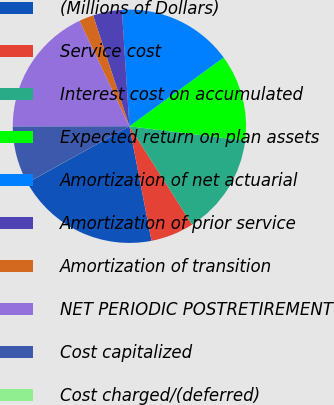Convert chart. <chart><loc_0><loc_0><loc_500><loc_500><pie_chart><fcel>(Millions of Dollars)<fcel>Service cost<fcel>Interest cost on accumulated<fcel>Expected return on plan assets<fcel>Amortization of net actuarial<fcel>Amortization of prior service<fcel>Amortization of transition<fcel>NET PERIODIC POSTRETIREMENT<fcel>Cost capitalized<fcel>Cost charged/(deferred)<nl><fcel>19.99%<fcel>6.0%<fcel>14.0%<fcel>12.0%<fcel>15.99%<fcel>4.01%<fcel>2.01%<fcel>17.99%<fcel>8.0%<fcel>0.01%<nl></chart> 